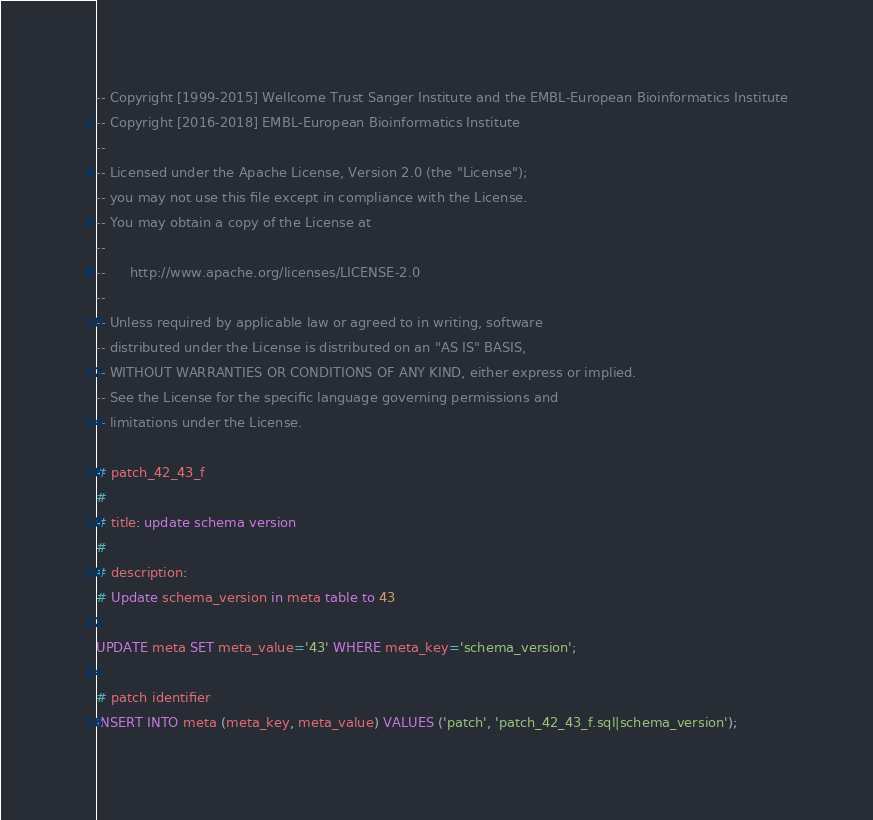Convert code to text. <code><loc_0><loc_0><loc_500><loc_500><_SQL_>-- Copyright [1999-2015] Wellcome Trust Sanger Institute and the EMBL-European Bioinformatics Institute
-- Copyright [2016-2018] EMBL-European Bioinformatics Institute
-- 
-- Licensed under the Apache License, Version 2.0 (the "License");
-- you may not use this file except in compliance with the License.
-- You may obtain a copy of the License at
-- 
--      http://www.apache.org/licenses/LICENSE-2.0
-- 
-- Unless required by applicable law or agreed to in writing, software
-- distributed under the License is distributed on an "AS IS" BASIS,
-- WITHOUT WARRANTIES OR CONDITIONS OF ANY KIND, either express or implied.
-- See the License for the specific language governing permissions and
-- limitations under the License.

# patch_42_43_f
#
# title: update schema version
#
# description:
# Update schema_version in meta table to 43

UPDATE meta SET meta_value='43' WHERE meta_key='schema_version';

# patch identifier
INSERT INTO meta (meta_key, meta_value) VALUES ('patch', 'patch_42_43_f.sql|schema_version');


</code> 